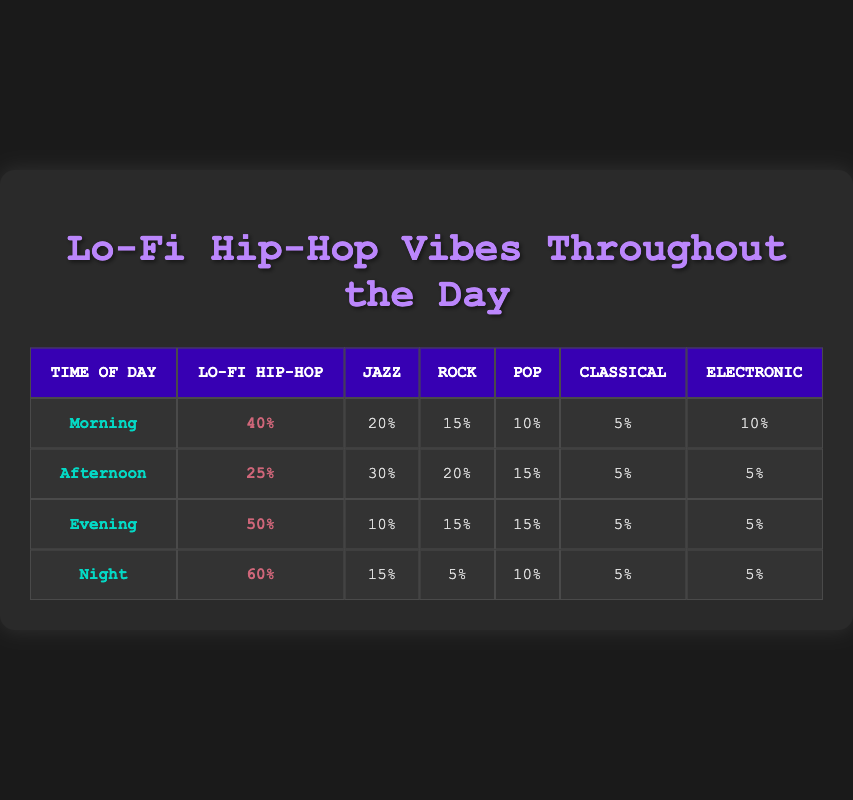What genre had the lowest frequency of listening during the afternoon? By examining the "Afternoon" row, we see the frequency for each genre: Lo-Fi Hip-Hop (25), Jazz (30), Rock (20), Pop (15), Classical (5), and Electronic (5). The lowest frequency is for Classical, which has a score of 5.
Answer: Classical What is the total frequency of listening to Lo-Fi Hip-Hop throughout the day? We sum the frequencies for Lo-Fi Hip-Hop across all time segments: Morning (40) + Afternoon (25) + Evening (50) + Night (60) = 175.
Answer: 175 During which time of day is Lo-Fi Hip-Hop listened to the most? The highest frequency for Lo-Fi Hip-Hop can be found in the row for Night, which has a count of 60 compared to other times: Morning (40), Afternoon (25), and Evening (50).
Answer: Night Is Jazz listened to more than Rock in the Evening? In the Evening row, Jazz has a frequency of 10 while Rock has a frequency of 15. Since 10 is not greater than 15, the answer is no.
Answer: No What is the average frequency of listening to electronic music throughout the day? The frequencies for Electronic across the times are: Morning (10), Afternoon (5), Evening (5), Night (5). To find the average, we sum these values: 10 + 5 + 5 + 5 = 25, and divide by the number of entries (4), giving us 25 / 4 = 6.25.
Answer: 6.25 Which genre had a higher frequency during the Night, Lo-Fi Hip-Hop or Jazz? We check the Night row: Lo-Fi Hip-Hop has 60 and Jazz has 15. Since 60 is greater than 15, we confirm that Lo-Fi Hip-Hop is the higher frequency genre.
Answer: Yes What genre had the highest total frequency across all times? We calculate the total frequency for each genre: Lo-Fi Hip-Hop (175), Jazz (75), Rock (55), Pop (50), Classical (20), and Electronic (25). The highest total is for Lo-Fi Hip-Hop at 175.
Answer: Lo-Fi Hip-Hop What is the difference in frequency of listening to Lo-Fi Hip-Hop between Morning and Night? In the Morning, Lo-Fi Hip-Hop has a frequency of 40, and at Night, it has 60. The difference is calculated as 60 - 40 = 20.
Answer: 20 